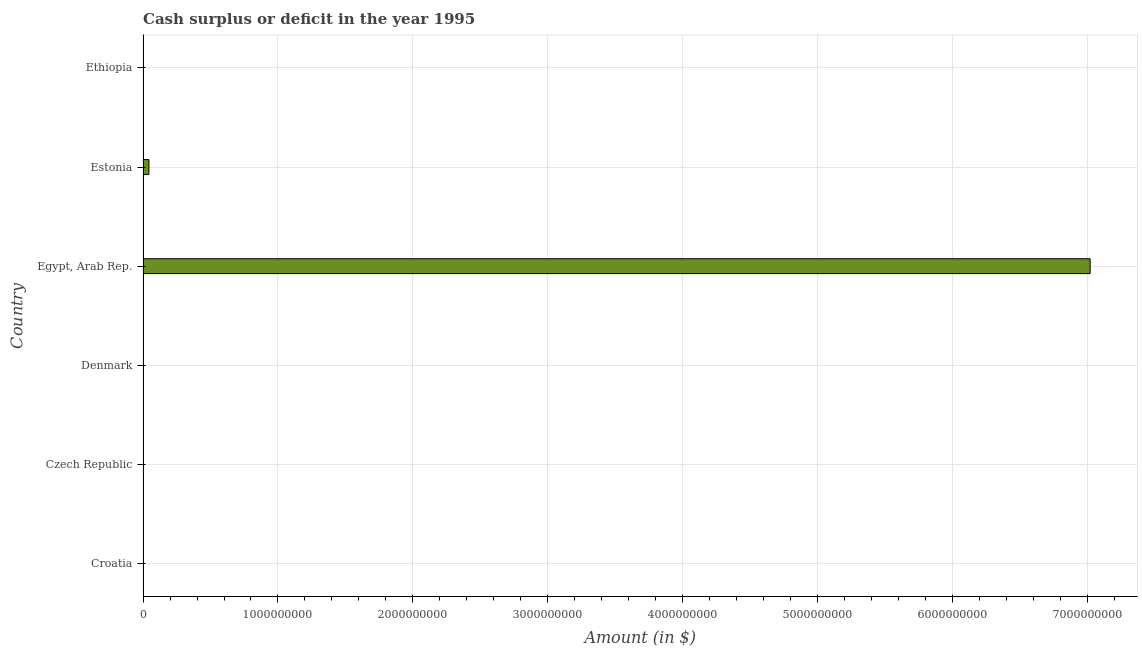Does the graph contain any zero values?
Give a very brief answer. Yes. Does the graph contain grids?
Provide a short and direct response. Yes. What is the title of the graph?
Make the answer very short. Cash surplus or deficit in the year 1995. What is the label or title of the X-axis?
Provide a succinct answer. Amount (in $). What is the label or title of the Y-axis?
Offer a terse response. Country. Across all countries, what is the maximum cash surplus or deficit?
Keep it short and to the point. 7.02e+09. In which country was the cash surplus or deficit maximum?
Provide a short and direct response. Egypt, Arab Rep. What is the sum of the cash surplus or deficit?
Keep it short and to the point. 7.06e+09. What is the average cash surplus or deficit per country?
Give a very brief answer. 1.18e+09. What is the difference between the highest and the lowest cash surplus or deficit?
Provide a short and direct response. 7.02e+09. In how many countries, is the cash surplus or deficit greater than the average cash surplus or deficit taken over all countries?
Your answer should be compact. 1. What is the difference between two consecutive major ticks on the X-axis?
Your answer should be compact. 1.00e+09. What is the Amount (in $) of Croatia?
Offer a very short reply. 0. What is the Amount (in $) in Egypt, Arab Rep.?
Ensure brevity in your answer.  7.02e+09. What is the Amount (in $) of Estonia?
Provide a succinct answer. 4.34e+07. What is the difference between the Amount (in $) in Egypt, Arab Rep. and Estonia?
Your answer should be compact. 6.98e+09. What is the ratio of the Amount (in $) in Egypt, Arab Rep. to that in Estonia?
Offer a very short reply. 161.77. 